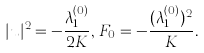<formula> <loc_0><loc_0><loc_500><loc_500>| u | ^ { 2 } = - \frac { \lambda _ { 1 } ^ { ( 0 ) } } { 2 K } , \, F _ { 0 } = - \frac { ( \lambda _ { 1 } ^ { ( 0 ) } ) ^ { 2 } } { K } .</formula> 